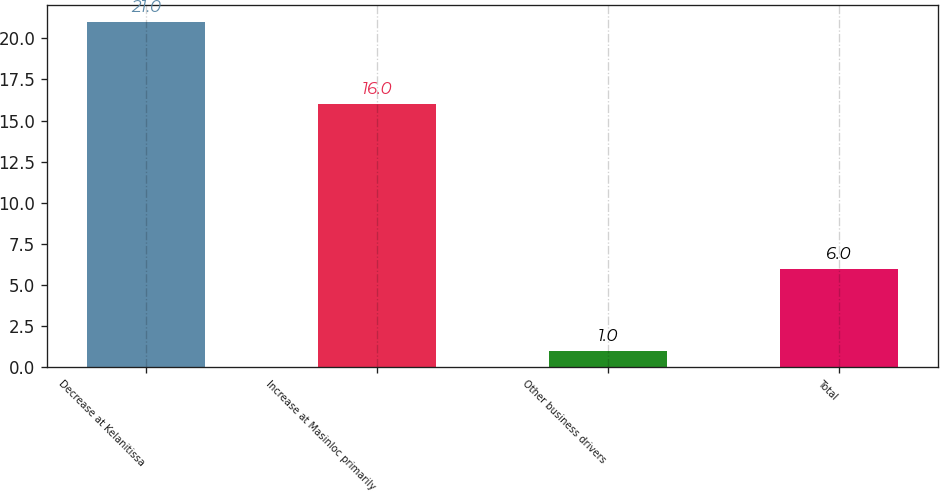Convert chart. <chart><loc_0><loc_0><loc_500><loc_500><bar_chart><fcel>Decrease at Kelanitissa<fcel>Increase at Masinloc primarily<fcel>Other business drivers<fcel>Total<nl><fcel>21<fcel>16<fcel>1<fcel>6<nl></chart> 